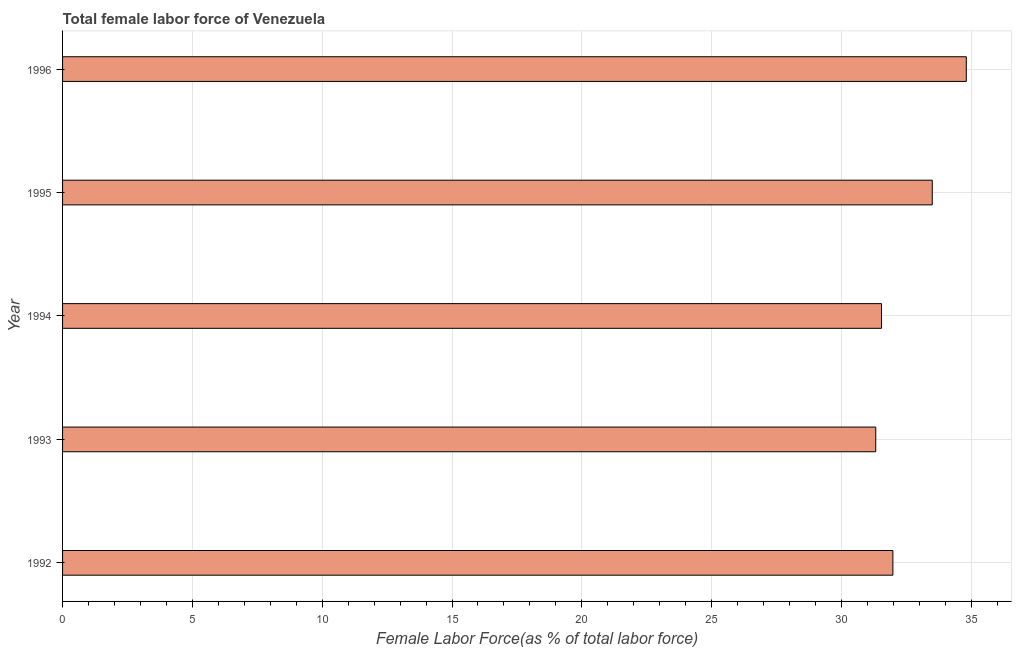Does the graph contain any zero values?
Keep it short and to the point. No. What is the title of the graph?
Offer a very short reply. Total female labor force of Venezuela. What is the label or title of the X-axis?
Your response must be concise. Female Labor Force(as % of total labor force). What is the label or title of the Y-axis?
Provide a short and direct response. Year. What is the total female labor force in 1996?
Make the answer very short. 34.81. Across all years, what is the maximum total female labor force?
Your answer should be very brief. 34.81. Across all years, what is the minimum total female labor force?
Keep it short and to the point. 31.32. In which year was the total female labor force minimum?
Give a very brief answer. 1993. What is the sum of the total female labor force?
Your answer should be compact. 163.15. What is the difference between the total female labor force in 1995 and 1996?
Keep it short and to the point. -1.31. What is the average total female labor force per year?
Keep it short and to the point. 32.63. What is the median total female labor force?
Make the answer very short. 31.98. Do a majority of the years between 1992 and 1994 (inclusive) have total female labor force greater than 9 %?
Provide a short and direct response. Yes. Is the total female labor force in 1994 less than that in 1995?
Offer a terse response. Yes. What is the difference between the highest and the second highest total female labor force?
Offer a very short reply. 1.31. What is the difference between the highest and the lowest total female labor force?
Your answer should be compact. 3.49. In how many years, is the total female labor force greater than the average total female labor force taken over all years?
Offer a very short reply. 2. Are all the bars in the graph horizontal?
Your response must be concise. Yes. How many years are there in the graph?
Provide a short and direct response. 5. What is the difference between two consecutive major ticks on the X-axis?
Offer a terse response. 5. What is the Female Labor Force(as % of total labor force) of 1992?
Your answer should be compact. 31.98. What is the Female Labor Force(as % of total labor force) of 1993?
Offer a very short reply. 31.32. What is the Female Labor Force(as % of total labor force) in 1994?
Give a very brief answer. 31.54. What is the Female Labor Force(as % of total labor force) of 1995?
Keep it short and to the point. 33.5. What is the Female Labor Force(as % of total labor force) in 1996?
Give a very brief answer. 34.81. What is the difference between the Female Labor Force(as % of total labor force) in 1992 and 1993?
Give a very brief answer. 0.66. What is the difference between the Female Labor Force(as % of total labor force) in 1992 and 1994?
Your answer should be very brief. 0.44. What is the difference between the Female Labor Force(as % of total labor force) in 1992 and 1995?
Make the answer very short. -1.52. What is the difference between the Female Labor Force(as % of total labor force) in 1992 and 1996?
Offer a very short reply. -2.83. What is the difference between the Female Labor Force(as % of total labor force) in 1993 and 1994?
Offer a terse response. -0.22. What is the difference between the Female Labor Force(as % of total labor force) in 1993 and 1995?
Provide a succinct answer. -2.18. What is the difference between the Female Labor Force(as % of total labor force) in 1993 and 1996?
Offer a terse response. -3.49. What is the difference between the Female Labor Force(as % of total labor force) in 1994 and 1995?
Make the answer very short. -1.95. What is the difference between the Female Labor Force(as % of total labor force) in 1994 and 1996?
Offer a very short reply. -3.27. What is the difference between the Female Labor Force(as % of total labor force) in 1995 and 1996?
Your answer should be compact. -1.31. What is the ratio of the Female Labor Force(as % of total labor force) in 1992 to that in 1994?
Keep it short and to the point. 1.01. What is the ratio of the Female Labor Force(as % of total labor force) in 1992 to that in 1995?
Offer a very short reply. 0.95. What is the ratio of the Female Labor Force(as % of total labor force) in 1992 to that in 1996?
Your answer should be very brief. 0.92. What is the ratio of the Female Labor Force(as % of total labor force) in 1993 to that in 1994?
Provide a succinct answer. 0.99. What is the ratio of the Female Labor Force(as % of total labor force) in 1993 to that in 1995?
Your answer should be very brief. 0.94. What is the ratio of the Female Labor Force(as % of total labor force) in 1994 to that in 1995?
Your response must be concise. 0.94. What is the ratio of the Female Labor Force(as % of total labor force) in 1994 to that in 1996?
Your answer should be very brief. 0.91. 